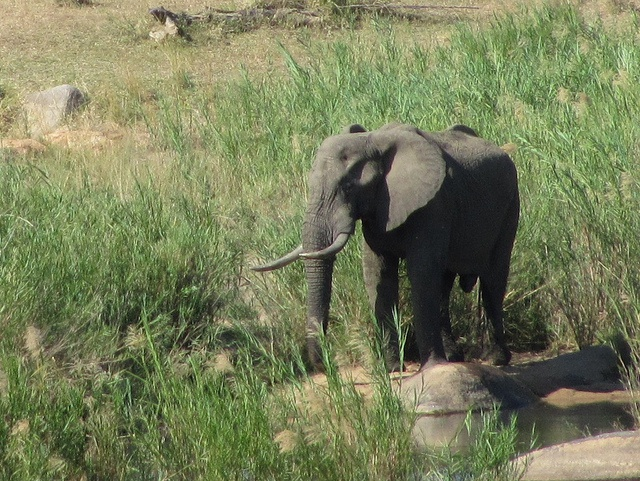Describe the objects in this image and their specific colors. I can see a elephant in tan, black, gray, and darkgray tones in this image. 